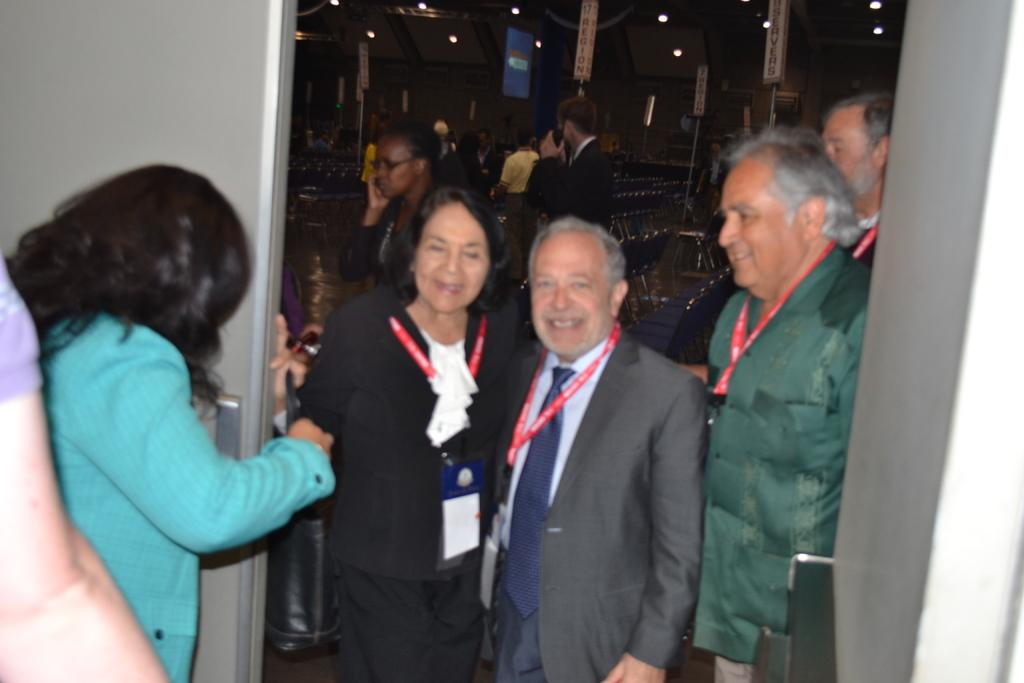What is the main focus of the image? The main focus of the image is the people in the center. What is located in the foreground of the image? There is a gate in the foreground of the image. What can be seen in the background of the image? There are chairs in the background of the image. What is visible at the top of the image? There are lights, banners, and a screen at the top of the image. Can you tell me how many times the grandmother has rocked the crib in the image? There is no mention of a grandmother or a crib in the image; the main focus is on the people, gate, chairs, lights, banners, and screen. 